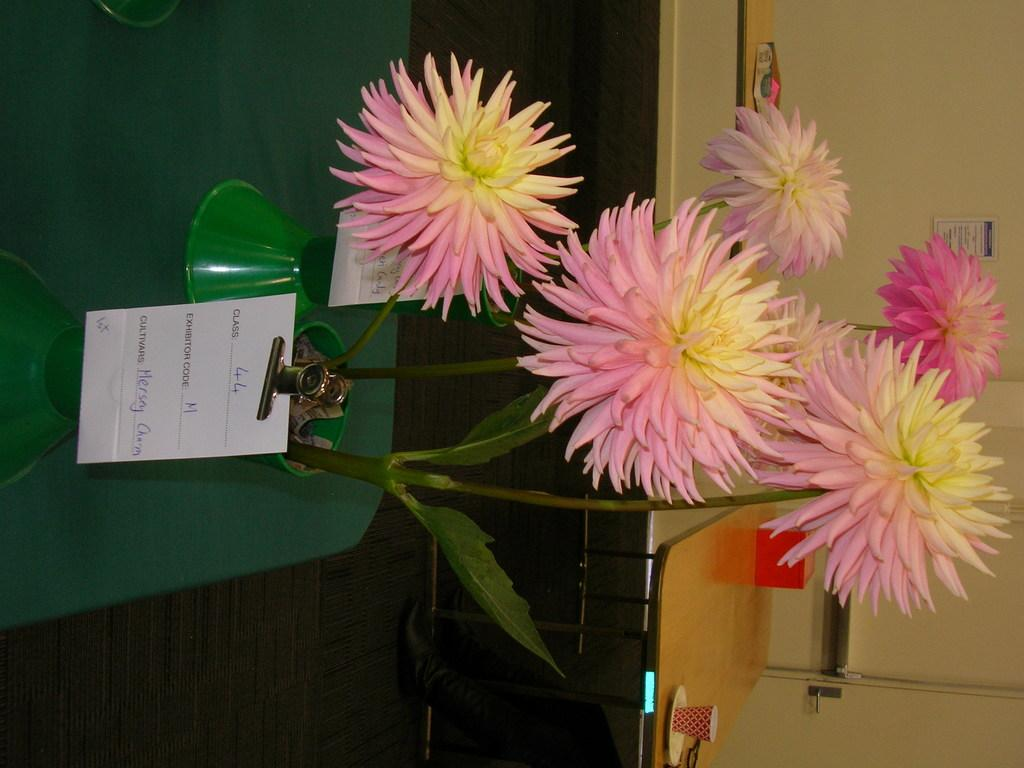What is the main piece of furniture in the image? There is a table in the image. What is placed on the table in the image? There is a flower vase on the table. Can you describe the background of the image? There is another table in the background, along with a cup and a box. What is visible on the wall in the image? The wall is visible in the image, but no specific details are provided about it. What type of account is being discussed in the image? There is no mention of an account in the image; it primarily features tables and objects on them. 